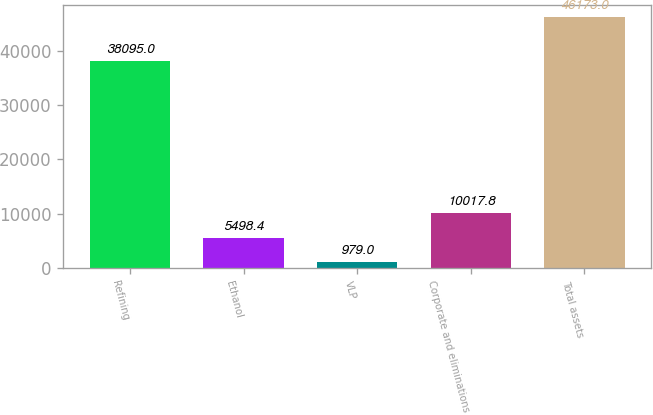<chart> <loc_0><loc_0><loc_500><loc_500><bar_chart><fcel>Refining<fcel>Ethanol<fcel>VLP<fcel>Corporate and eliminations<fcel>Total assets<nl><fcel>38095<fcel>5498.4<fcel>979<fcel>10017.8<fcel>46173<nl></chart> 